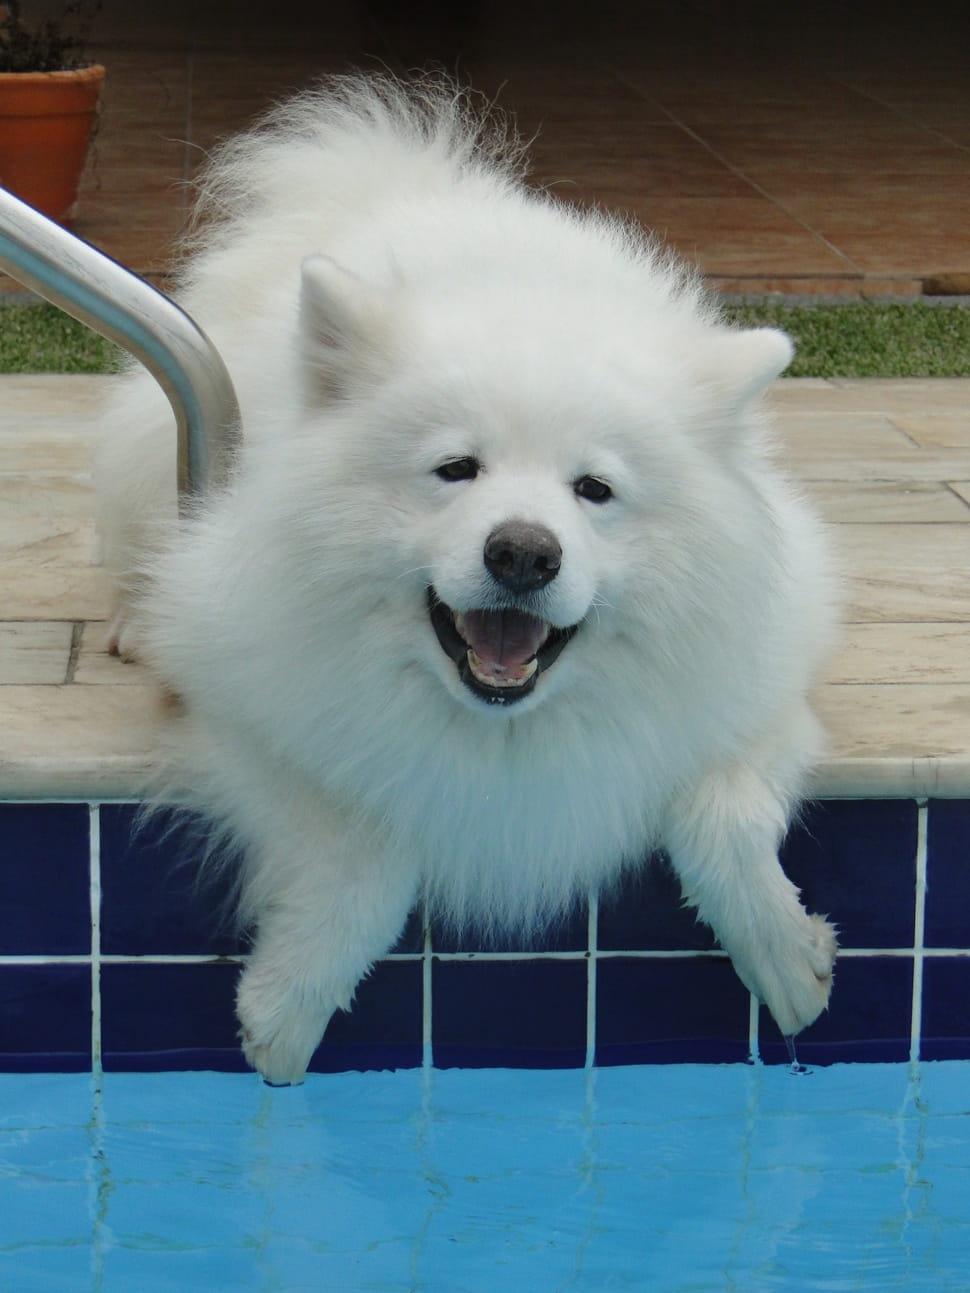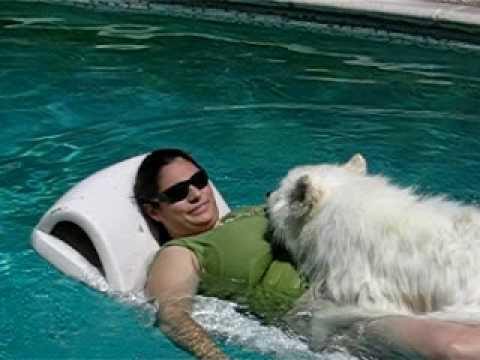The first image is the image on the left, the second image is the image on the right. Evaluate the accuracy of this statement regarding the images: "Both dogs are swimming in the water.". Is it true? Answer yes or no. No. The first image is the image on the left, the second image is the image on the right. Assess this claim about the two images: "There is a dog swimming to the right in both images.". Correct or not? Answer yes or no. No. 